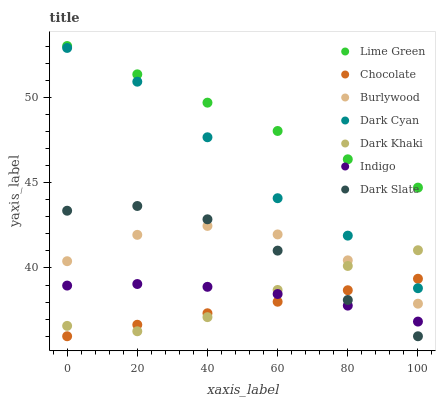Does Chocolate have the minimum area under the curve?
Answer yes or no. Yes. Does Lime Green have the maximum area under the curve?
Answer yes or no. Yes. Does Burlywood have the minimum area under the curve?
Answer yes or no. No. Does Burlywood have the maximum area under the curve?
Answer yes or no. No. Is Chocolate the smoothest?
Answer yes or no. Yes. Is Burlywood the roughest?
Answer yes or no. Yes. Is Burlywood the smoothest?
Answer yes or no. No. Is Chocolate the roughest?
Answer yes or no. No. Does Chocolate have the lowest value?
Answer yes or no. Yes. Does Burlywood have the lowest value?
Answer yes or no. No. Does Lime Green have the highest value?
Answer yes or no. Yes. Does Burlywood have the highest value?
Answer yes or no. No. Is Dark Slate less than Dark Cyan?
Answer yes or no. Yes. Is Lime Green greater than Dark Slate?
Answer yes or no. Yes. Does Indigo intersect Dark Slate?
Answer yes or no. Yes. Is Indigo less than Dark Slate?
Answer yes or no. No. Is Indigo greater than Dark Slate?
Answer yes or no. No. Does Dark Slate intersect Dark Cyan?
Answer yes or no. No. 